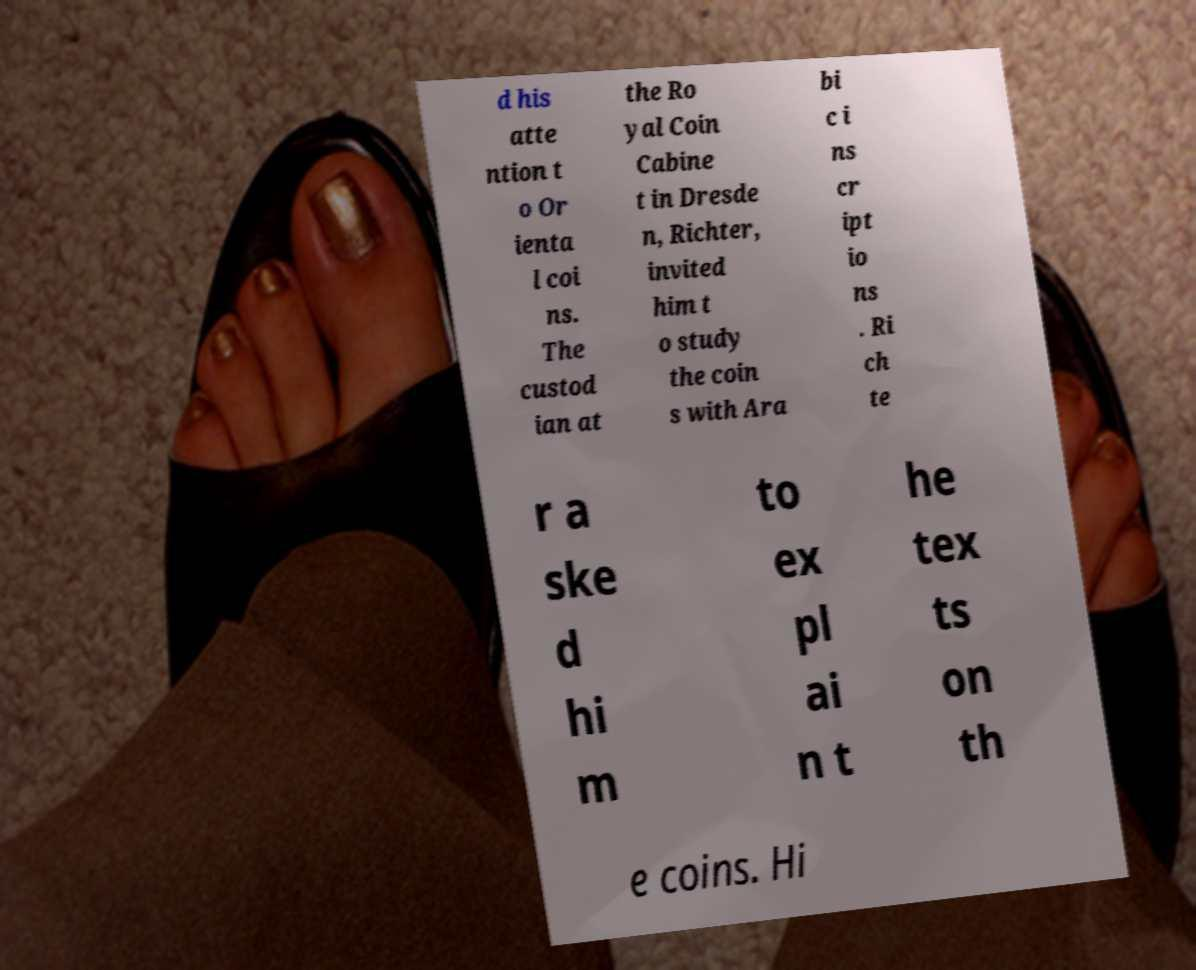Please read and relay the text visible in this image. What does it say? d his atte ntion t o Or ienta l coi ns. The custod ian at the Ro yal Coin Cabine t in Dresde n, Richter, invited him t o study the coin s with Ara bi c i ns cr ipt io ns . Ri ch te r a ske d hi m to ex pl ai n t he tex ts on th e coins. Hi 